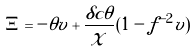Convert formula to latex. <formula><loc_0><loc_0><loc_500><loc_500>\Xi = - \theta v + { \frac { \delta c \theta } { \chi } } ( 1 - f ^ { - 2 } v )</formula> 